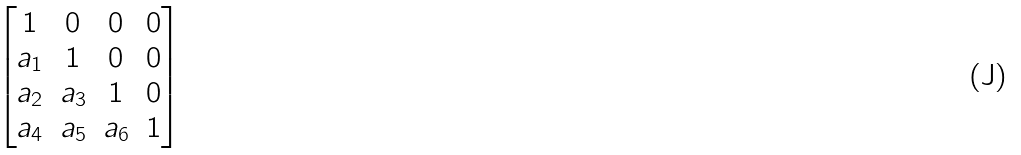Convert formula to latex. <formula><loc_0><loc_0><loc_500><loc_500>\begin{bmatrix} 1 & 0 & 0 & 0 \\ a _ { 1 } & 1 & 0 & 0 \\ a _ { 2 } & a _ { 3 } & 1 & 0 \\ a _ { 4 } & a _ { 5 } & a _ { 6 } & 1 \end{bmatrix}</formula> 